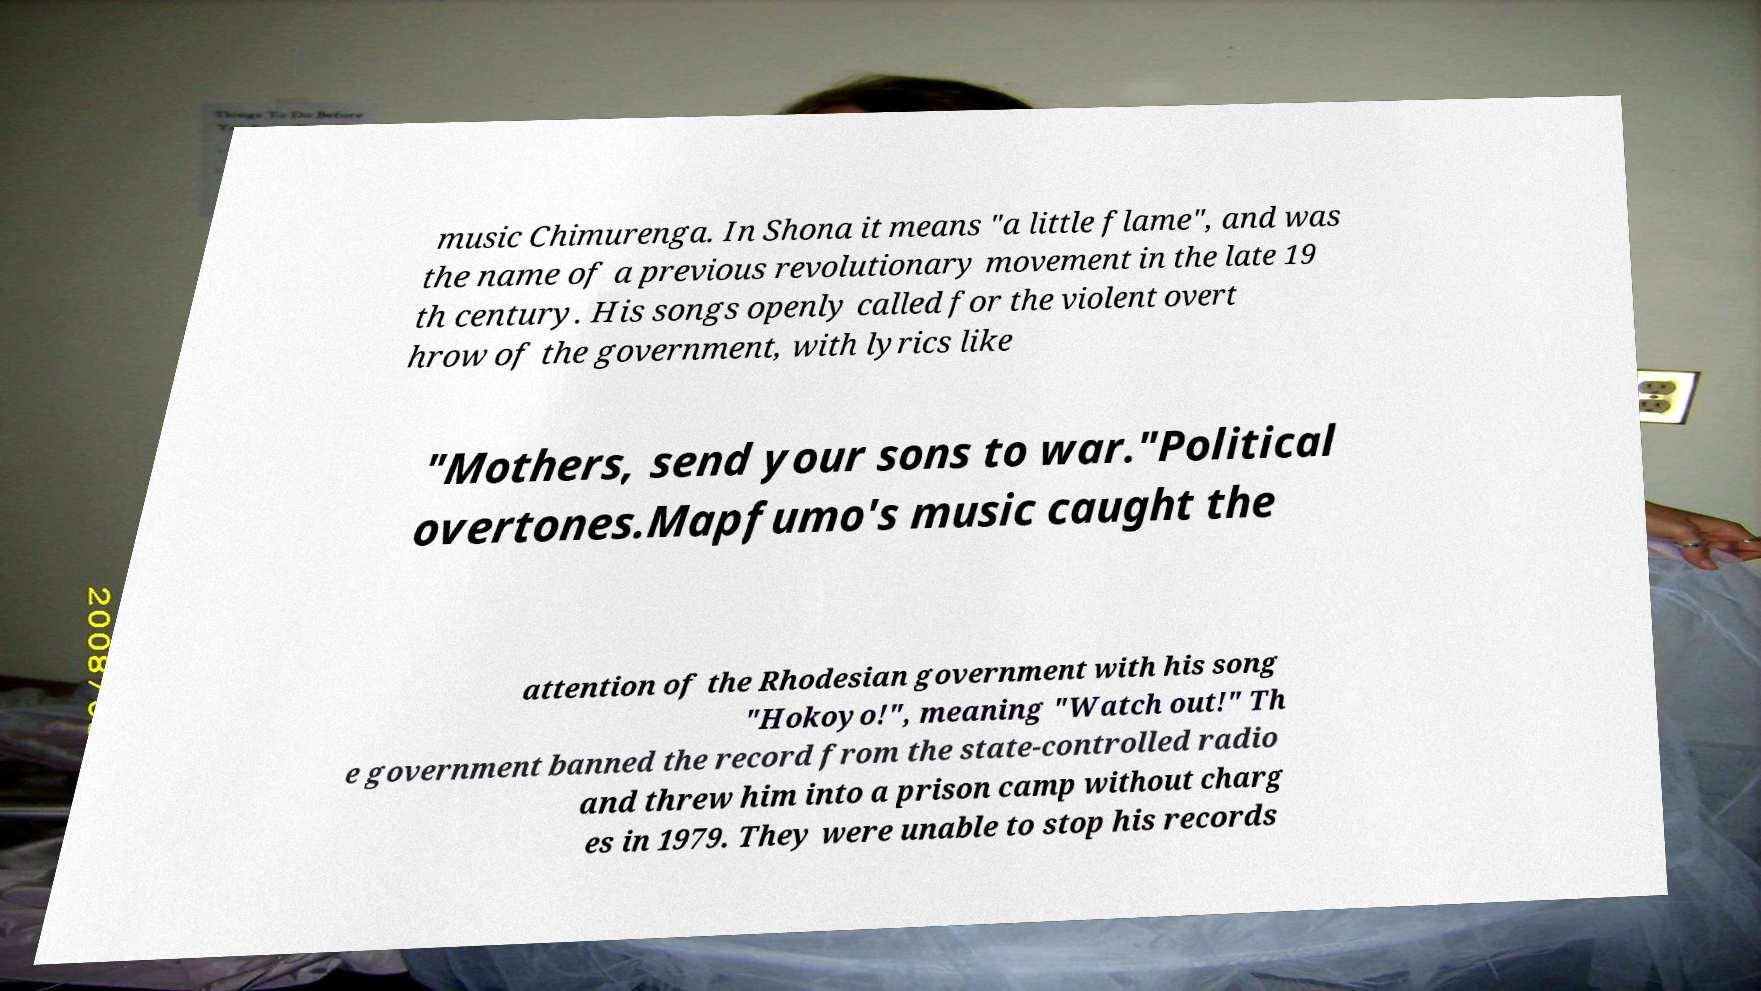Please identify and transcribe the text found in this image. music Chimurenga. In Shona it means "a little flame", and was the name of a previous revolutionary movement in the late 19 th century. His songs openly called for the violent overt hrow of the government, with lyrics like "Mothers, send your sons to war."Political overtones.Mapfumo's music caught the attention of the Rhodesian government with his song "Hokoyo!", meaning "Watch out!" Th e government banned the record from the state-controlled radio and threw him into a prison camp without charg es in 1979. They were unable to stop his records 